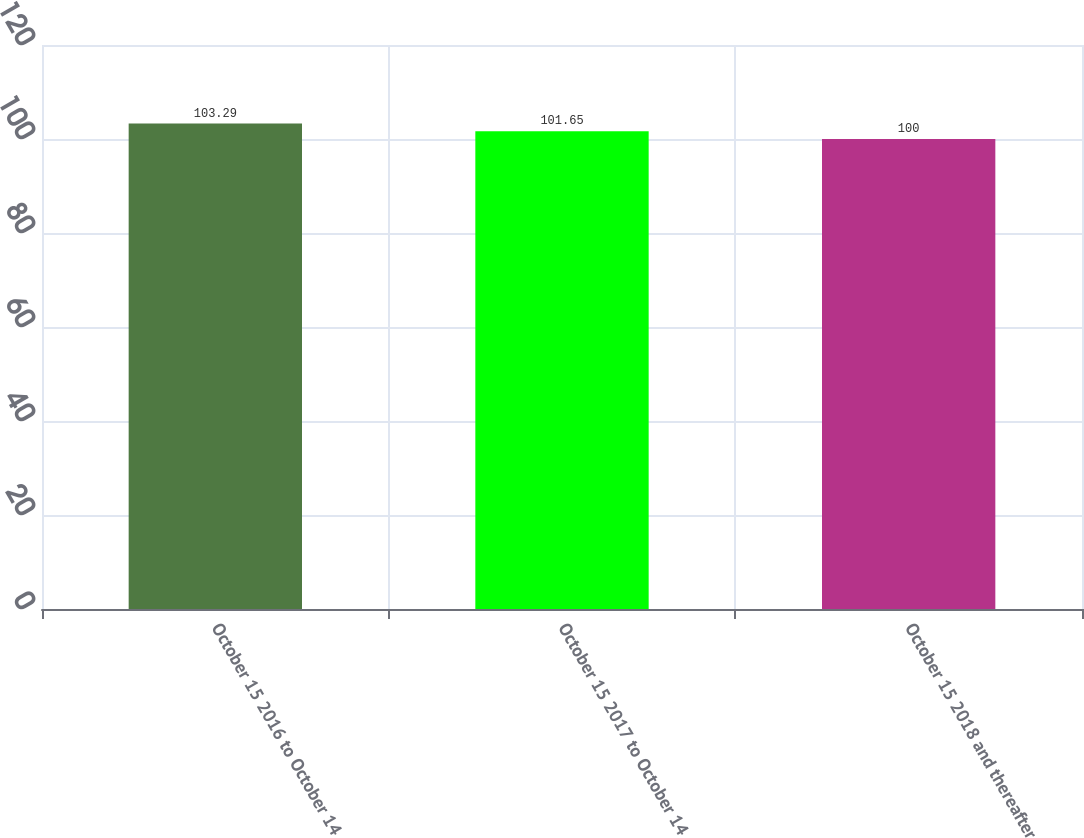Convert chart to OTSL. <chart><loc_0><loc_0><loc_500><loc_500><bar_chart><fcel>October 15 2016 to October 14<fcel>October 15 2017 to October 14<fcel>October 15 2018 and thereafter<nl><fcel>103.29<fcel>101.65<fcel>100<nl></chart> 